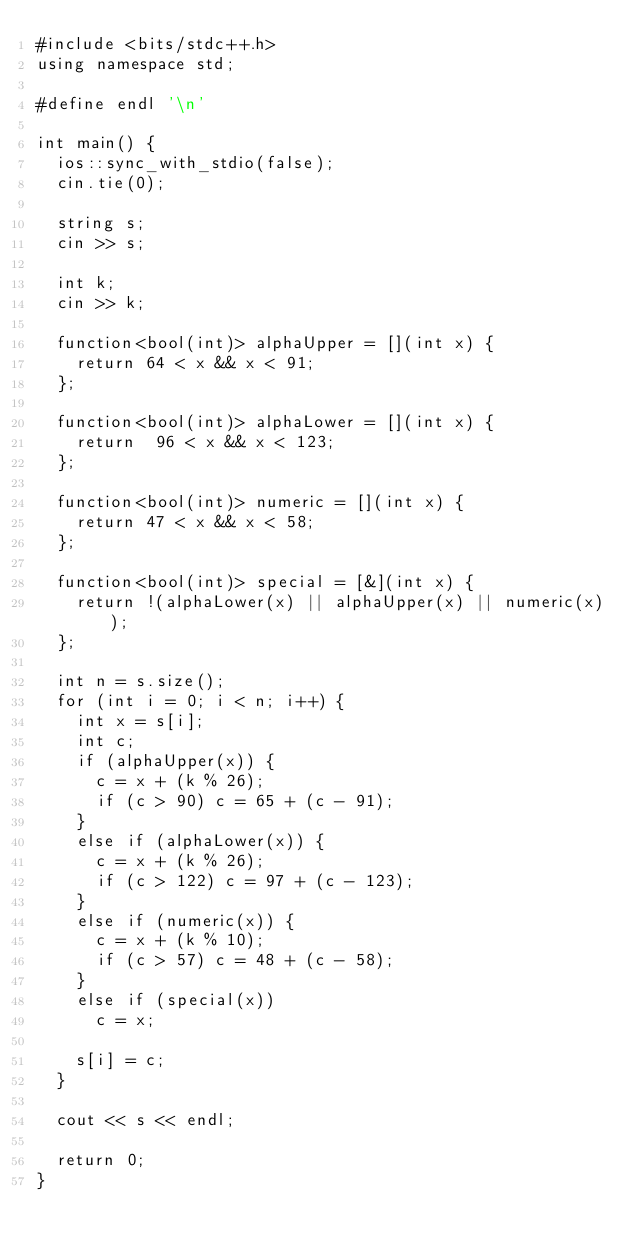<code> <loc_0><loc_0><loc_500><loc_500><_C++_>#include <bits/stdc++.h>
using namespace std;

#define endl '\n'

int main() {
  ios::sync_with_stdio(false);
  cin.tie(0);

  string s;
  cin >> s;

  int k;
  cin >> k;

  function<bool(int)> alphaUpper = [](int x) {
    return 64 < x && x < 91;
  };

  function<bool(int)> alphaLower = [](int x) {
    return  96 < x && x < 123;
  };

  function<bool(int)> numeric = [](int x) {
    return 47 < x && x < 58;
  };

  function<bool(int)> special = [&](int x) {
    return !(alphaLower(x) || alphaUpper(x) || numeric(x));
  };

  int n = s.size();
  for (int i = 0; i < n; i++) {
    int x = s[i];
    int c;
    if (alphaUpper(x)) {
      c = x + (k % 26);
      if (c > 90) c = 65 + (c - 91);
    }
    else if (alphaLower(x)) {
      c = x + (k % 26);
      if (c > 122) c = 97 + (c - 123);
    }
    else if (numeric(x)) {
      c = x + (k % 10);
      if (c > 57) c = 48 + (c - 58);
    }
    else if (special(x))
      c = x;

    s[i] = c;
  }

  cout << s << endl;

  return 0;
}

</code> 